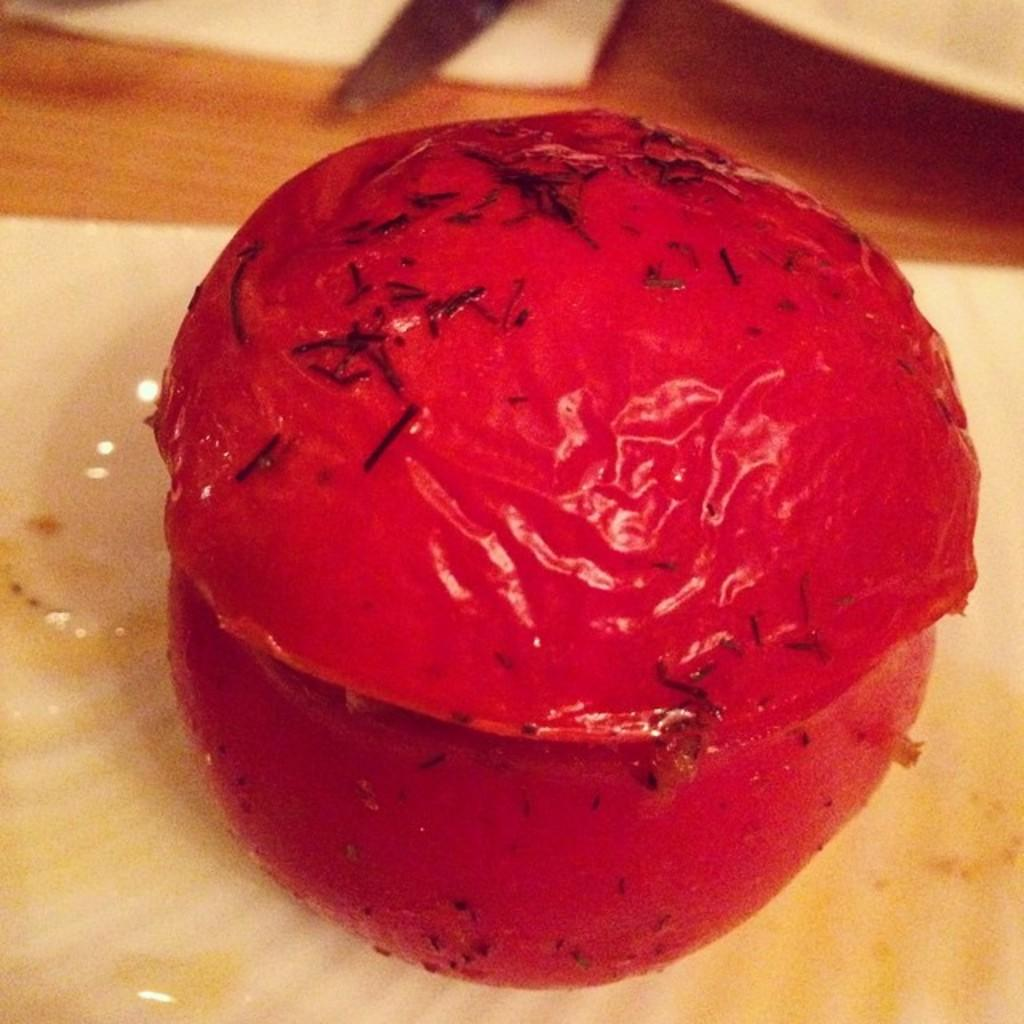What is the main subject of the image? There is a food item in the image. Where is the food item located? The food item is on an object. What else can be seen in the image besides the food item? There are objects visible at the top of the image. What type of pollution can be seen in the image? There is no reference to pollution in the image, so it cannot be determined if any pollution is present. 